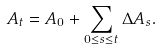Convert formula to latex. <formula><loc_0><loc_0><loc_500><loc_500>A _ { t } = A _ { 0 } + \sum _ { 0 \leq s \leq t } \Delta A _ { s } .</formula> 